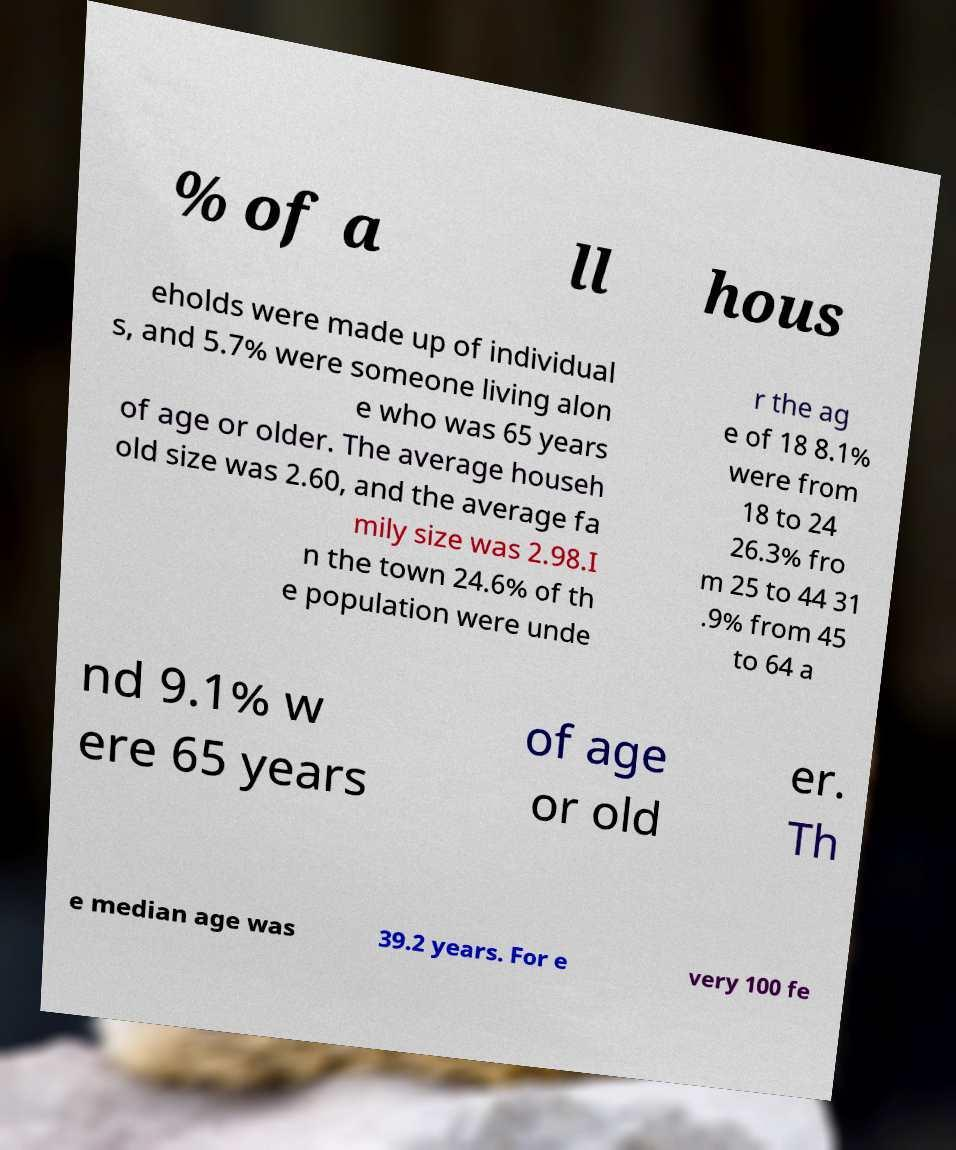What messages or text are displayed in this image? I need them in a readable, typed format. % of a ll hous eholds were made up of individual s, and 5.7% were someone living alon e who was 65 years of age or older. The average househ old size was 2.60, and the average fa mily size was 2.98.I n the town 24.6% of th e population were unde r the ag e of 18 8.1% were from 18 to 24 26.3% fro m 25 to 44 31 .9% from 45 to 64 a nd 9.1% w ere 65 years of age or old er. Th e median age was 39.2 years. For e very 100 fe 